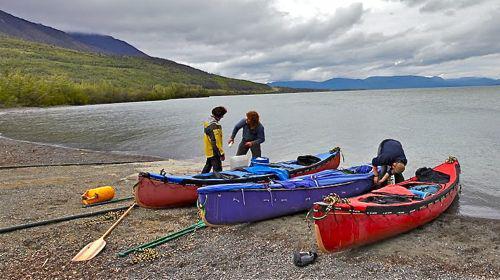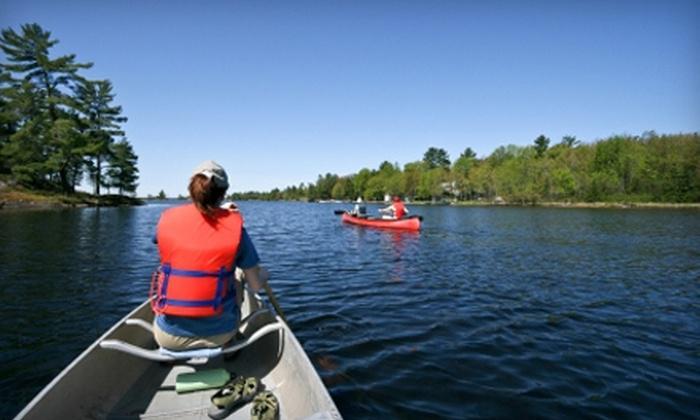The first image is the image on the left, the second image is the image on the right. Given the left and right images, does the statement "At least three yellow kayaks are arranged in a row in one of the images." hold true? Answer yes or no. No. The first image is the image on the left, the second image is the image on the right. Analyze the images presented: Is the assertion "rows of yellow canoes line the beach" valid? Answer yes or no. No. 